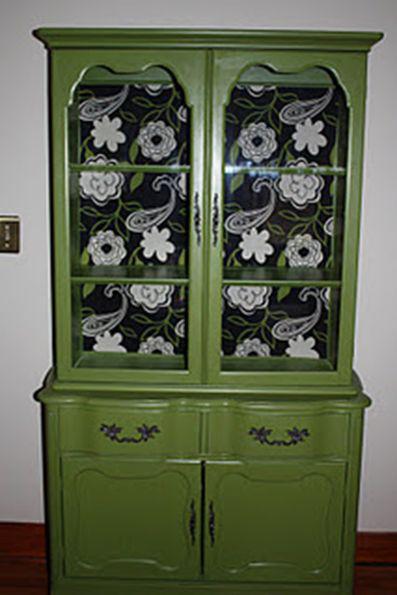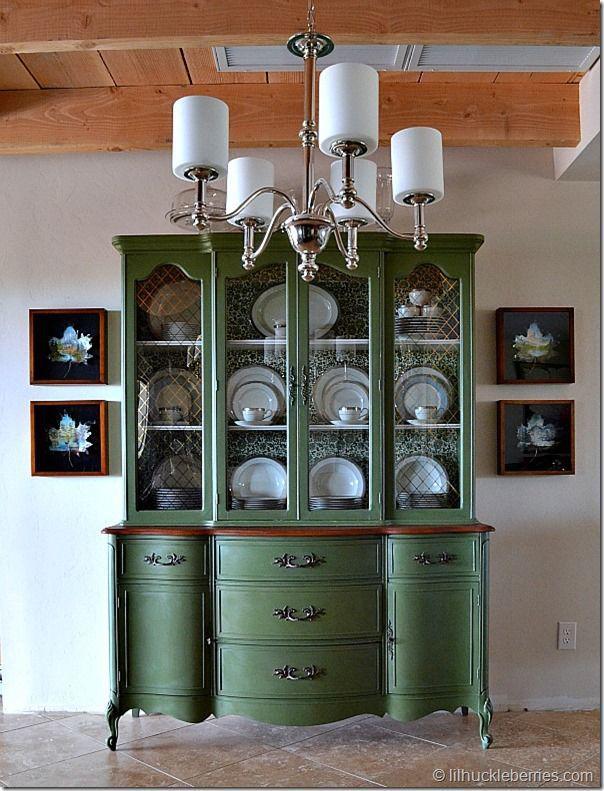The first image is the image on the left, the second image is the image on the right. Examine the images to the left and right. Is the description "There is a plant on the side of the cabinet in the image on the left." accurate? Answer yes or no. No. The first image is the image on the left, the second image is the image on the right. For the images displayed, is the sentence "At least one of the cabinets is greenish, with a flat top and scrollwork with legs at the bottom." factually correct? Answer yes or no. Yes. 